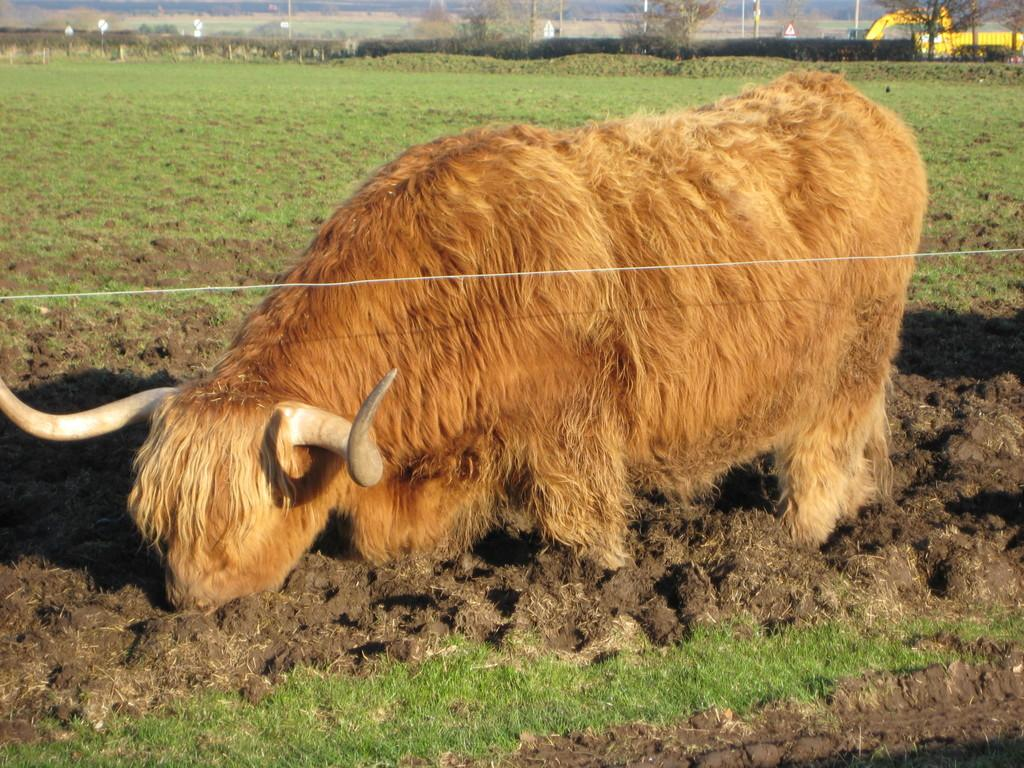What animal is present in the image? There is a yak in the image. What is the yak's location in the image? The yak is standing in the mud. Where is the yak located in terms of the environment? The yak is on a grass field. What type of coach can be seen in the image? There is no coach present in the image; it features a yak standing in the mud on a grass field. What reward is the yak receiving for standing in the mud? There is no reward being given to the yak in the image; it is simply standing in the mud on a grass field. 